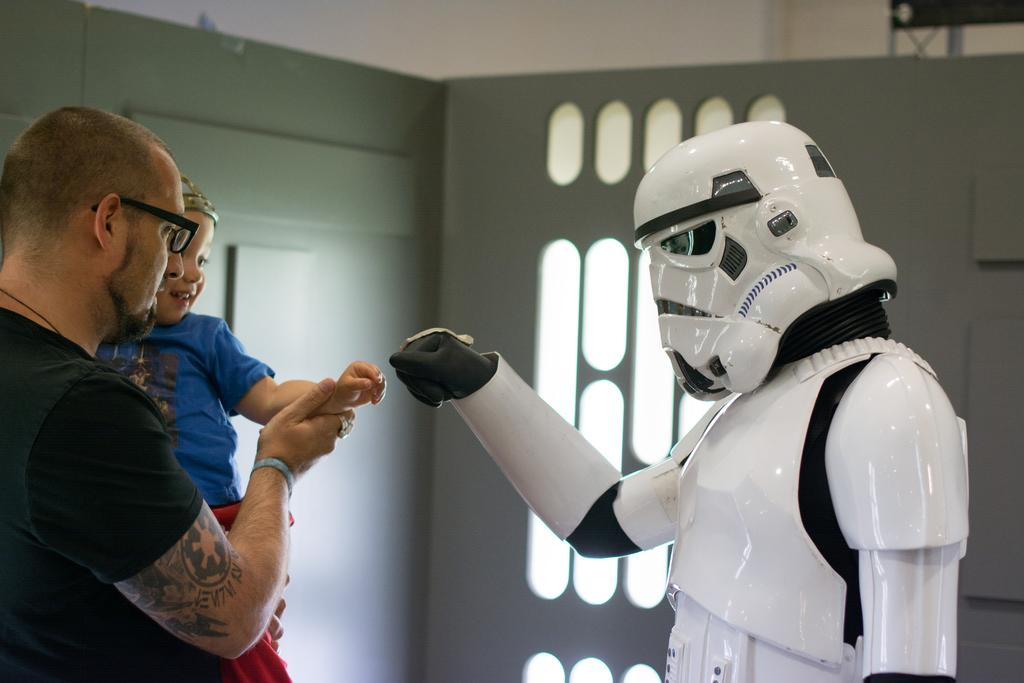What is the person in the image doing with the baby? The person is holding the baby in the image. Can you describe the appearance of the person holding the baby? The person holding the baby is wearing spectacles. What is the costume-wearing person doing in the image? There is a person wearing a costume in the image, but their actions are not specified. What can be seen in the background of the image? There is a wall in the background of the image. What type of watch is the baby wearing in the image? There is no watch visible on the baby in the image. What kind of cub is present in the image? There is no cub present in the image. 